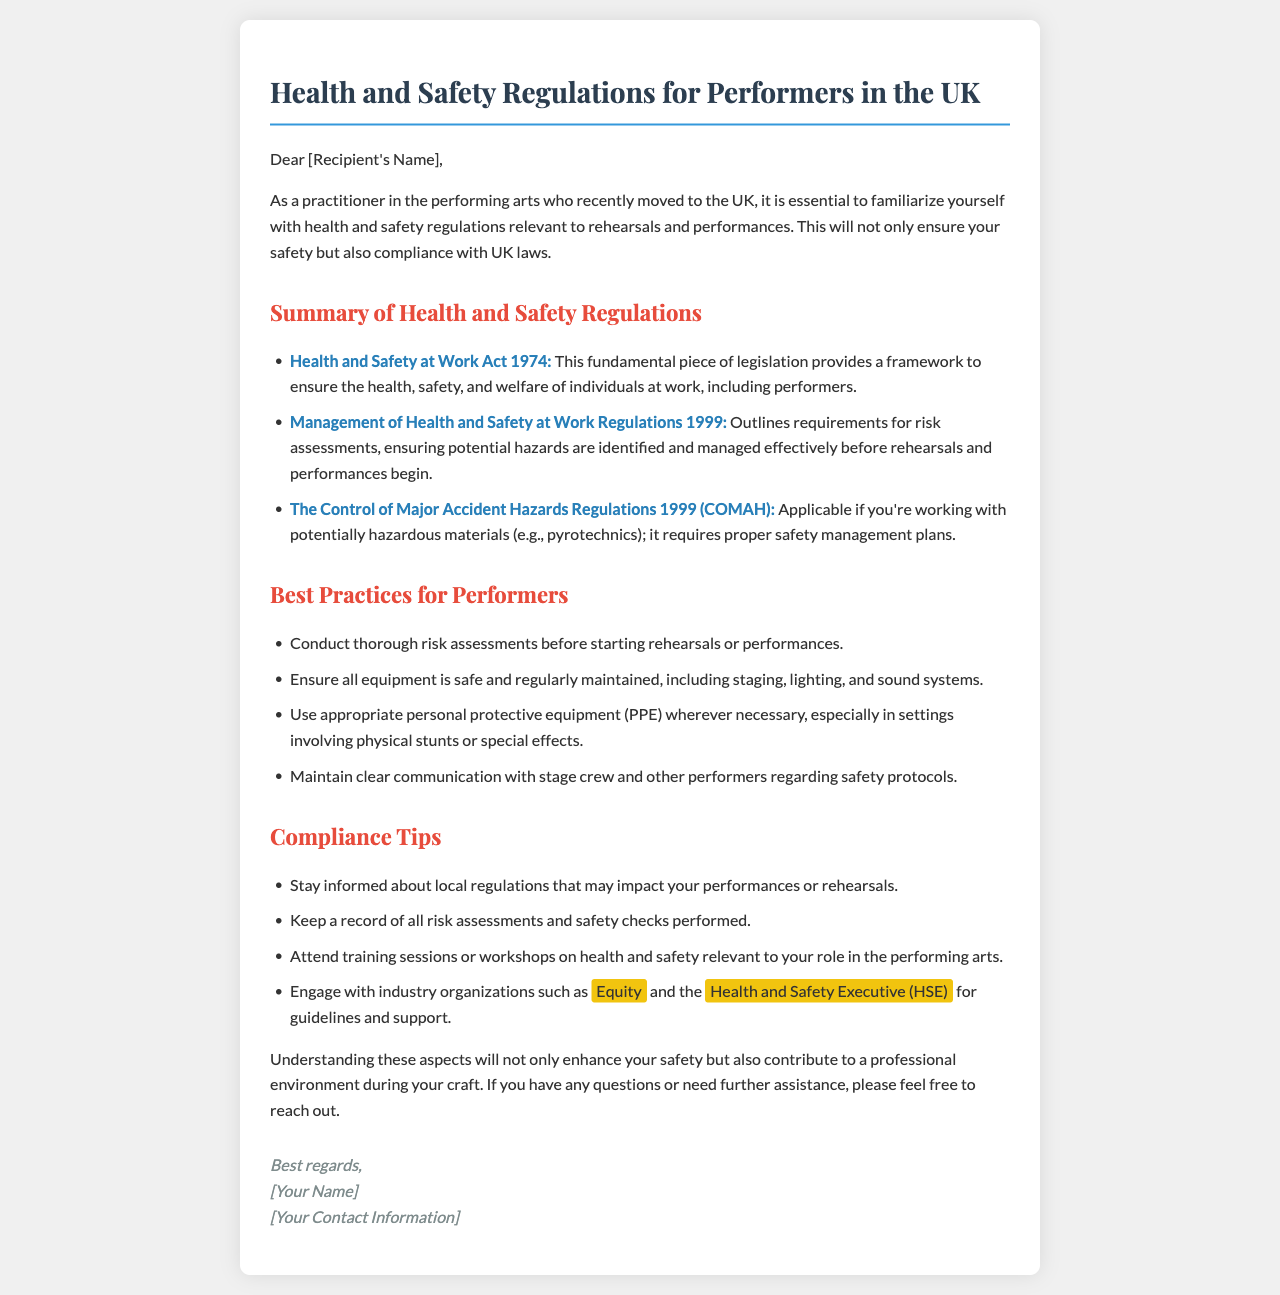What is the primary legislation for health and safety at work? The primary legislation mentioned in the document is the Health and Safety at Work Act 1974, which provides a framework for ensuring health, safety, and welfare.
Answer: Health and Safety at Work Act 1974 What year were the Management of Health and Safety at Work Regulations established? The document states that the Management of Health and Safety at Work Regulations were established in 1999.
Answer: 1999 Name one industry organization mentioned for health and safety support. The document mentions Equity as one of the industry organizations for health and safety support in performing arts.
Answer: Equity What should performers maintain clear communication about? The document indicates that performers should maintain clear communication regarding safety protocols with the stage crew and other performers.
Answer: Safety protocols How often should equipment be maintained according to best practices? The document suggests that all equipment should be regularly maintained, which implies a consistent schedule.
Answer: Regularly What type of equipment is suggested for use in hazardous settings? The document recommends using appropriate personal protective equipment (PPE) whenever necessary, especially in hazardous settings.
Answer: Personal protective equipment (PPE) Which regulation addresses major accident hazards? The document states that the Control of Major Accident Hazards Regulations 1999 (COMAH) addresses major accident hazards.
Answer: Control of Major Accident Hazards Regulations 1999 (COMAH) What is the main goal of performing risk assessments before rehearsals? The main goal of conducting risk assessments is to ensure potential hazards are identified and managed effectively before rehearsals and performances.
Answer: Identify and manage potential hazards 